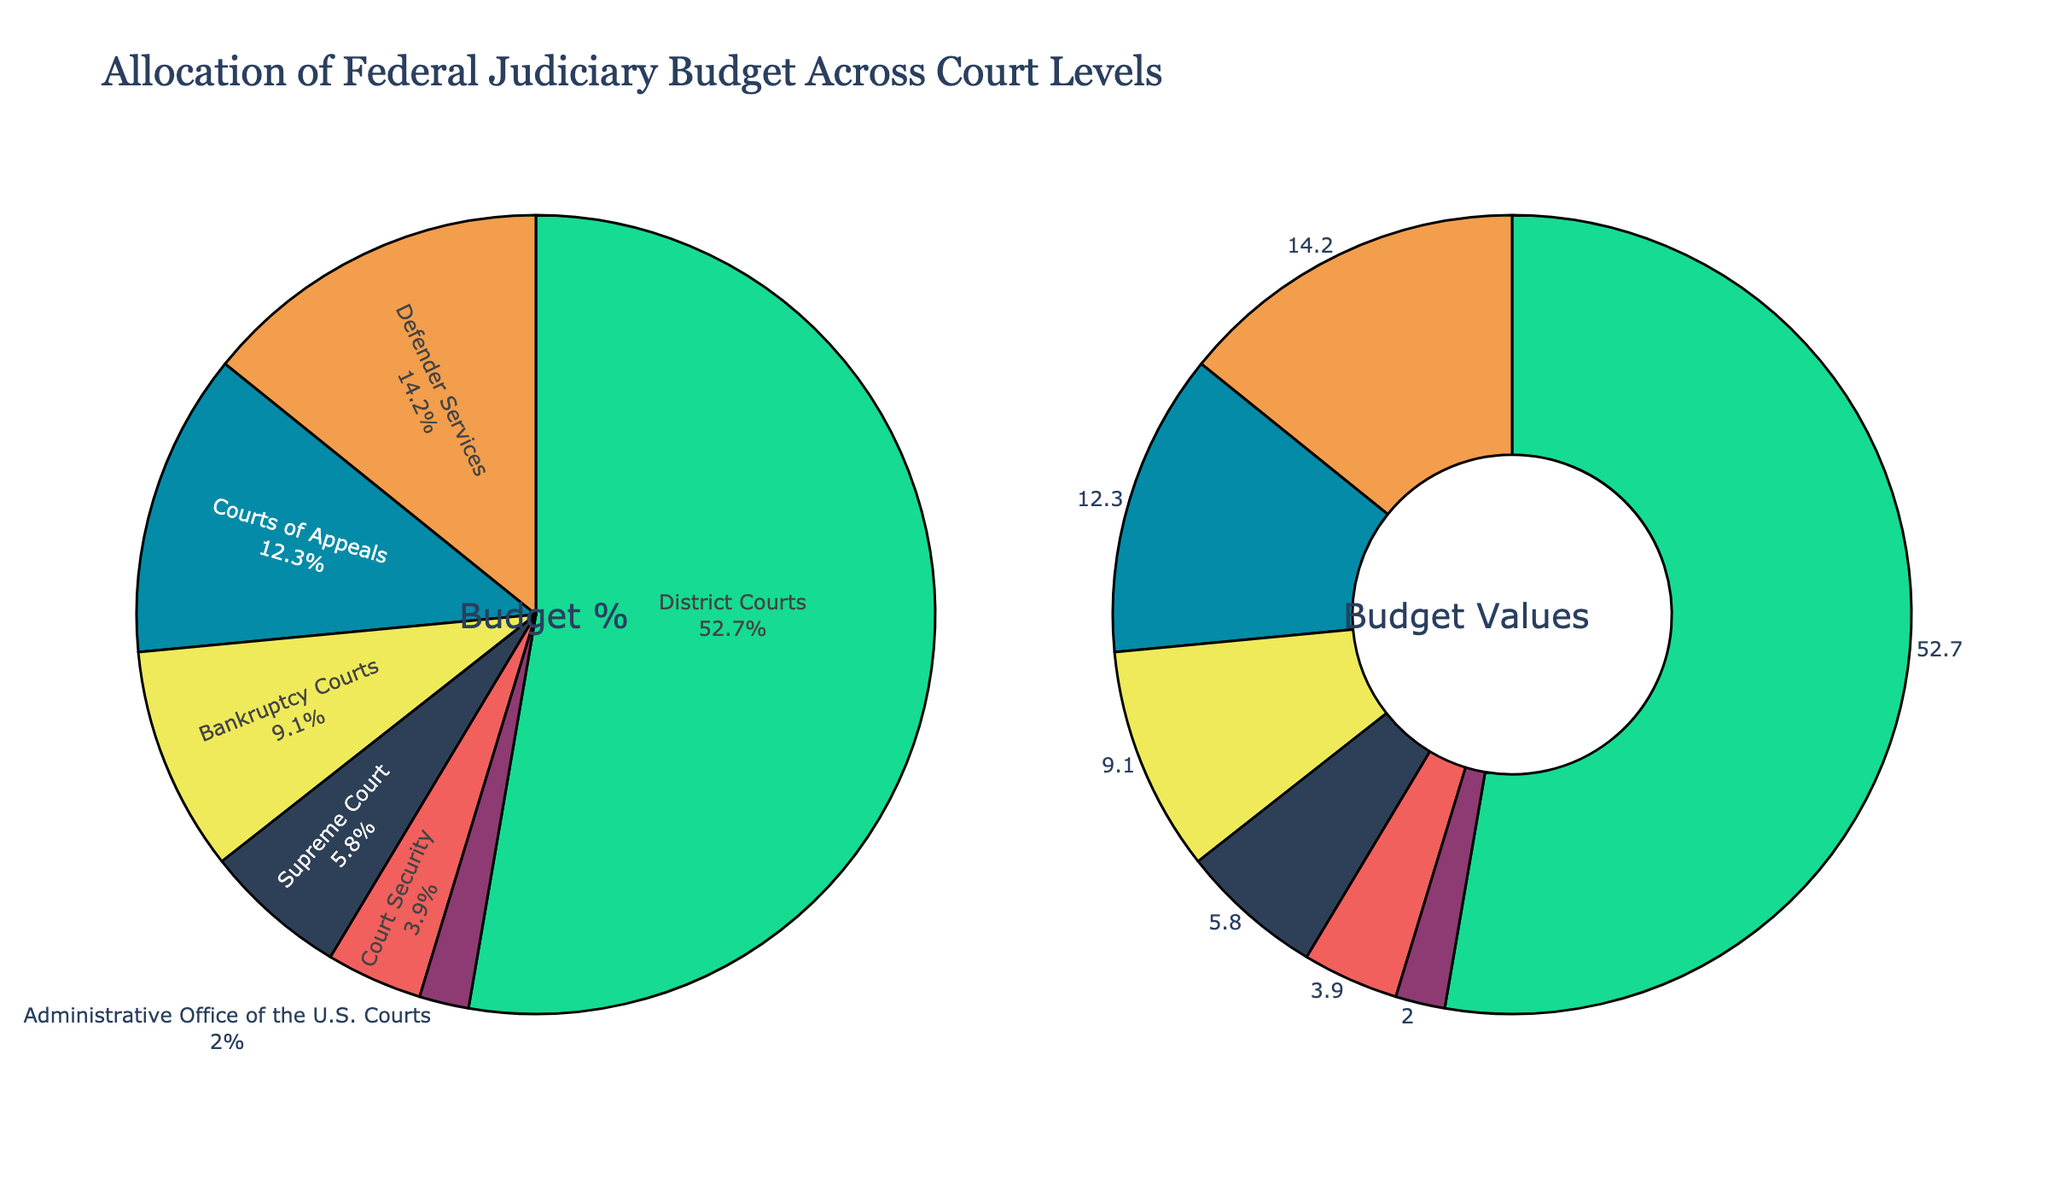What percentage of the federal judiciary budget is allocated to the District Courts? The pie chart on the left side shows labels and percentages for each court level. From the chart, we can see that the District Courts have a 52.7% allocation.
Answer: 52.7% What is the combined budget allocation percentage for the Supreme Court and Bankruptcy Courts? From the pie chart, the Supreme Court has 5.8% and Bankruptcy Courts have 9.1%. Adding these together gives 5.8% + 9.1% = 14.9%.
Answer: 14.9% Among the court levels, which has the smallest budget allocation, and what is it? Looking at the pie chart showing the percentages, the Administrative Office of the U.S. Courts has the smallest allocation at 2.0%.
Answer: Administrative Office of the U.S. Courts, 2.0% How does the budget allocation for Defender Services compare to Courts of Appeals? The pie chart indicates that Defender Services has a 14.2% allocation, while Courts of Appeals has a 12.3% allocation. Defender Services, therefore, receives a greater share.
Answer: Defender Services > Courts of Appeals Which court level has the second-largest budget allocation, and what is its percentage? From the percentages shown in the pie chart, the District Courts have the largest allocation at 52.7%. The next largest is Defender Services with 14.2%.
Answer: Defender Services, 14.2% What is the difference in budget allocation between the Supreme Court and Court Security? The pie chart shows that the Supreme Court has a 5.8% allocation, while Court Security has a 3.9% allocation. The difference is 5.8% - 3.9% = 1.9%.
Answer: 1.9% Which colored section of the pie chart represents the Courts of Appeals? From the visual attributes of the pie chart, the Courts of Appeals are represented by the color light blue.
Answer: light blue What is the total budget allocation percentage for the District Courts, Bankruptcy Courts, and Defender Services combined? From the pie chart, their percentages are District Courts 52.7%, Bankruptcy Courts 9.1%, and Defender Services 14.2%. Adding these together gives 52.7% + 9.1% + 14.2% = 76.0%.
Answer: 76.0% How many court levels have a budget allocation of less than 10%? By looking at the pie chart, the following court levels have less than 10% allocation: Supreme Court (5.8%), Bankruptcy Courts (9.1%), Court Security (3.9%), and Administrative Office of the U.S. Courts (2.0%). There are 4 court levels in total with less than 10%.
Answer: 4 What fraction of the budget is not allocated to the District Courts? The District Courts receive 52.7% of the budget. Thus, the budget not allocated to the District Courts is 100% - 52.7% = 47.3%.
Answer: 47.3% 